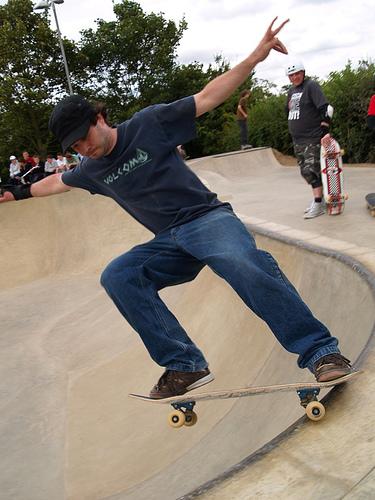How many hands are on the skateboard?
Write a very short answer. 0. What trick is being performed?
Concise answer only. Grind. Are all of the wheels of the skateboard on the ground?
Be succinct. No. How many skateboards are there?
Give a very brief answer. 2. 